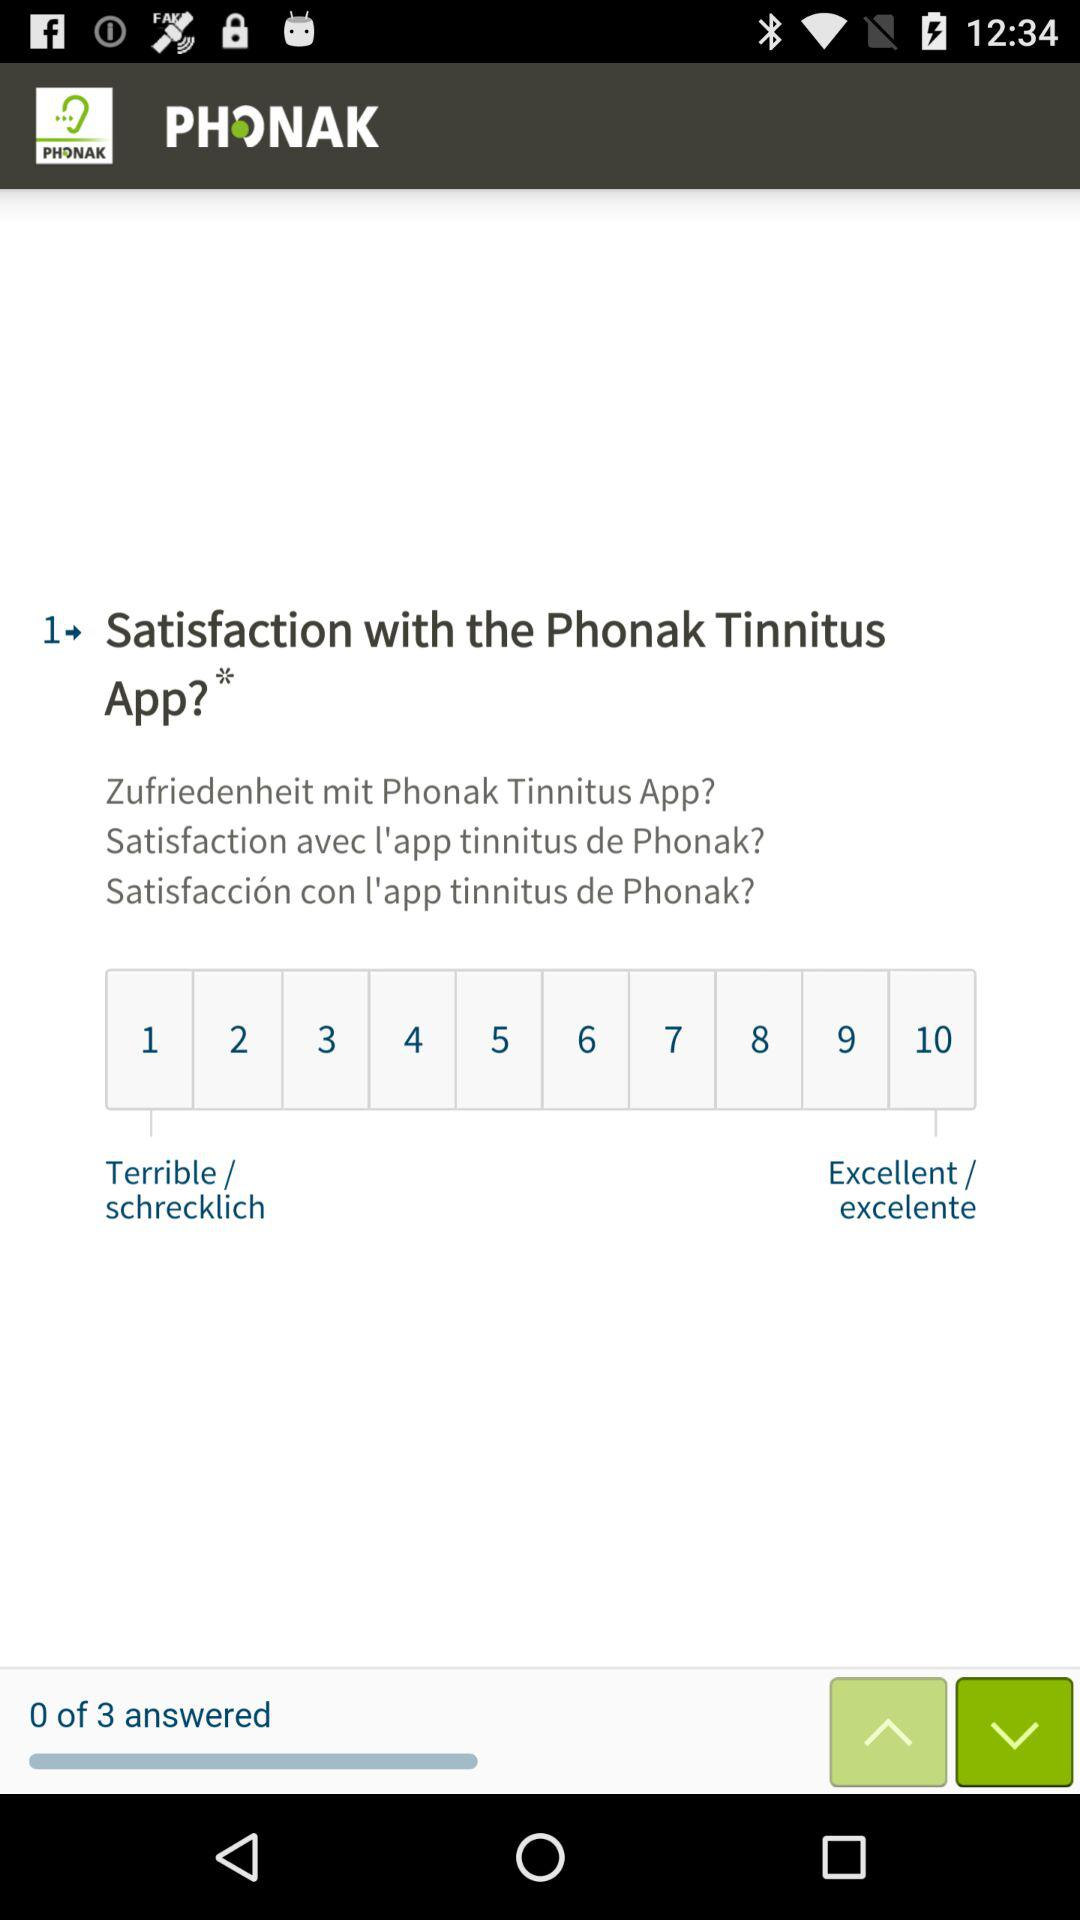How many satisfaction options are available?
Answer the question using a single word or phrase. 10 